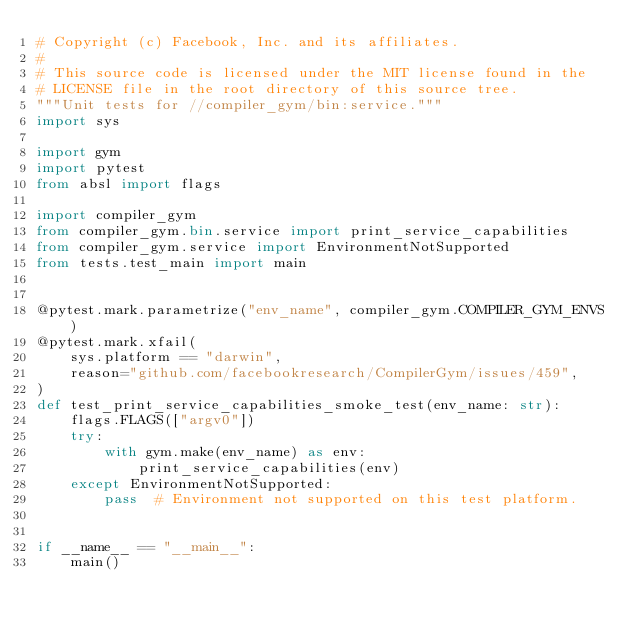Convert code to text. <code><loc_0><loc_0><loc_500><loc_500><_Python_># Copyright (c) Facebook, Inc. and its affiliates.
#
# This source code is licensed under the MIT license found in the
# LICENSE file in the root directory of this source tree.
"""Unit tests for //compiler_gym/bin:service."""
import sys

import gym
import pytest
from absl import flags

import compiler_gym
from compiler_gym.bin.service import print_service_capabilities
from compiler_gym.service import EnvironmentNotSupported
from tests.test_main import main


@pytest.mark.parametrize("env_name", compiler_gym.COMPILER_GYM_ENVS)
@pytest.mark.xfail(
    sys.platform == "darwin",
    reason="github.com/facebookresearch/CompilerGym/issues/459",
)
def test_print_service_capabilities_smoke_test(env_name: str):
    flags.FLAGS(["argv0"])
    try:
        with gym.make(env_name) as env:
            print_service_capabilities(env)
    except EnvironmentNotSupported:
        pass  # Environment not supported on this test platform.


if __name__ == "__main__":
    main()
</code> 